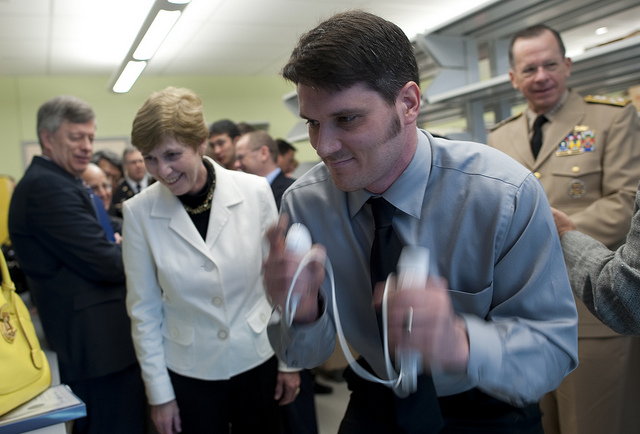Can you describe the emotions or mood in this image? The mood in the image is one of engagement and curiosity. The person at the front seems concentrated on his task, and the observers, especially the woman in the white jacket, exhibit expressions of interest and attentiveness to the activity being performed. 